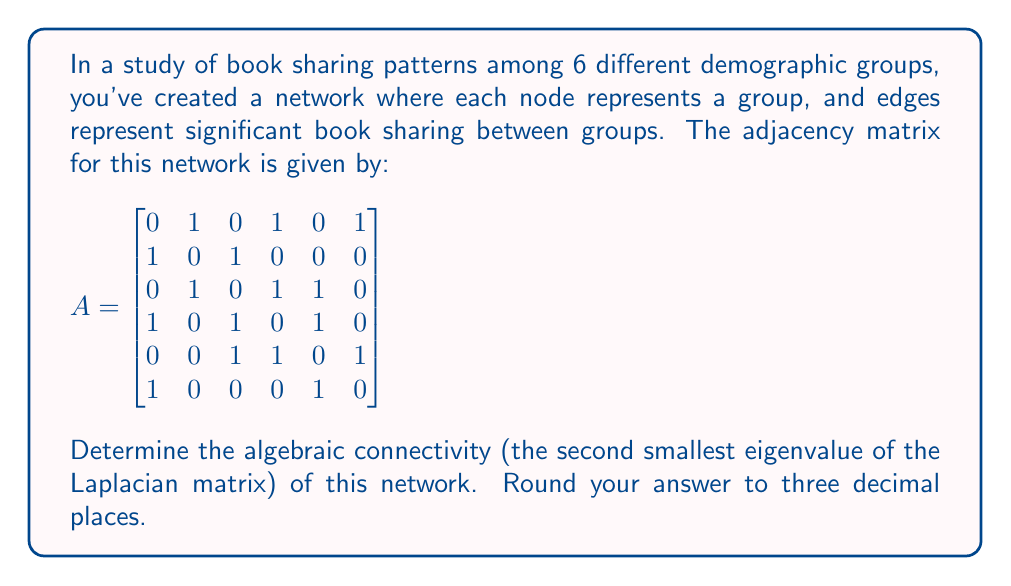Help me with this question. To solve this problem, we'll follow these steps:

1) First, we need to calculate the Laplacian matrix L. The Laplacian matrix is defined as L = D - A, where D is the degree matrix and A is the adjacency matrix.

2) The degree matrix D is a diagonal matrix where each diagonal element is the degree of the corresponding node. We can calculate this from the adjacency matrix:

$$
D = \begin{bmatrix}
3 & 0 & 0 & 0 & 0 & 0 \\
0 & 2 & 0 & 0 & 0 & 0 \\
0 & 0 & 3 & 0 & 0 & 0 \\
0 & 0 & 0 & 3 & 0 & 0 \\
0 & 0 & 0 & 0 & 3 & 0 \\
0 & 0 & 0 & 0 & 0 & 2
\end{bmatrix}
$$

3) Now we can calculate the Laplacian matrix L = D - A:

$$
L = \begin{bmatrix}
3 & -1 & 0 & -1 & 0 & -1 \\
-1 & 2 & -1 & 0 & 0 & 0 \\
0 & -1 & 3 & -1 & -1 & 0 \\
-1 & 0 & -1 & 3 & -1 & 0 \\
0 & 0 & -1 & -1 & 3 & -1 \\
-1 & 0 & 0 & 0 & -1 & 2
\end{bmatrix}
$$

4) The eigenvalues of L can be calculated using numerical methods. Using a computer algebra system, we find the eigenvalues (rounded to 3 decimal places) are:

   $\{0.000, 0.722, 2.000, 2.764, 3.696, 5.818\}$

5) The algebraic connectivity is the second smallest eigenvalue, which is 0.722.

This value gives us information about the overall connectivity of the network. A higher value indicates better connectivity, with the theoretical maximum being the number of nodes (6 in this case) for a complete graph.
Answer: 0.722 